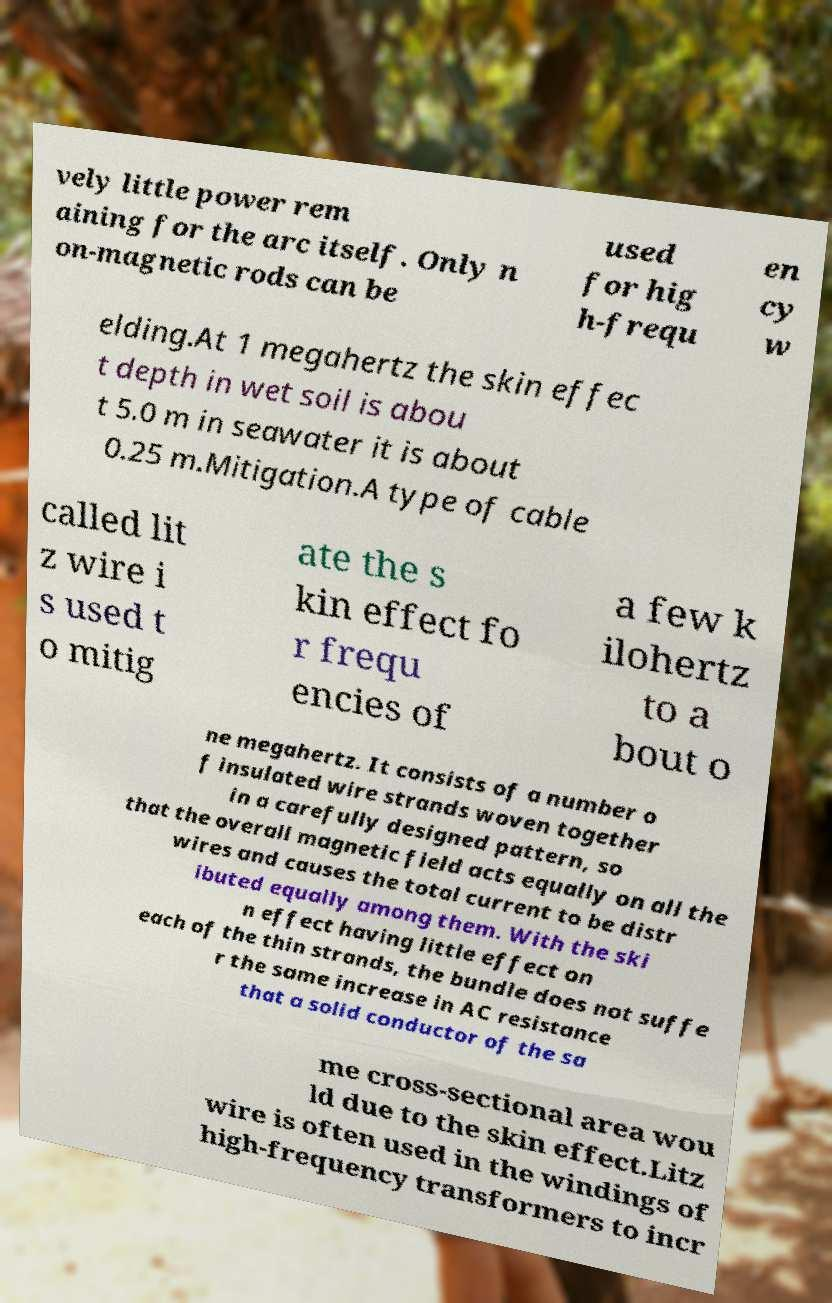For documentation purposes, I need the text within this image transcribed. Could you provide that? vely little power rem aining for the arc itself. Only n on-magnetic rods can be used for hig h-frequ en cy w elding.At 1 megahertz the skin effec t depth in wet soil is abou t 5.0 m in seawater it is about 0.25 m.Mitigation.A type of cable called lit z wire i s used t o mitig ate the s kin effect fo r frequ encies of a few k ilohertz to a bout o ne megahertz. It consists of a number o f insulated wire strands woven together in a carefully designed pattern, so that the overall magnetic field acts equally on all the wires and causes the total current to be distr ibuted equally among them. With the ski n effect having little effect on each of the thin strands, the bundle does not suffe r the same increase in AC resistance that a solid conductor of the sa me cross-sectional area wou ld due to the skin effect.Litz wire is often used in the windings of high-frequency transformers to incr 